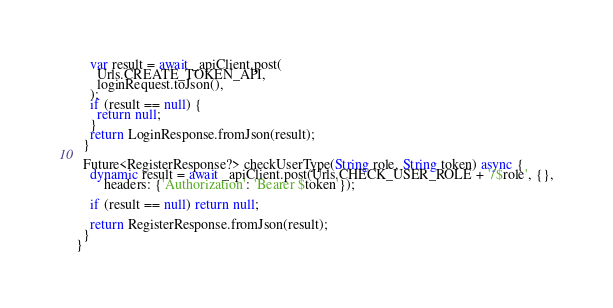Convert code to text. <code><loc_0><loc_0><loc_500><loc_500><_Dart_>    var result = await _apiClient.post(
      Urls.CREATE_TOKEN_API,
      loginRequest.toJson(),
    );
    if (result == null) {
      return null;
    }
    return LoginResponse.fromJson(result);
  }

  Future<RegisterResponse?> checkUserType(String role, String token) async {
    dynamic result = await _apiClient.post(Urls.CHECK_USER_ROLE + '/$role', {},
        headers: {'Authorization': 'Bearer $token'});

    if (result == null) return null;

    return RegisterResponse.fromJson(result);
  }
}
</code> 